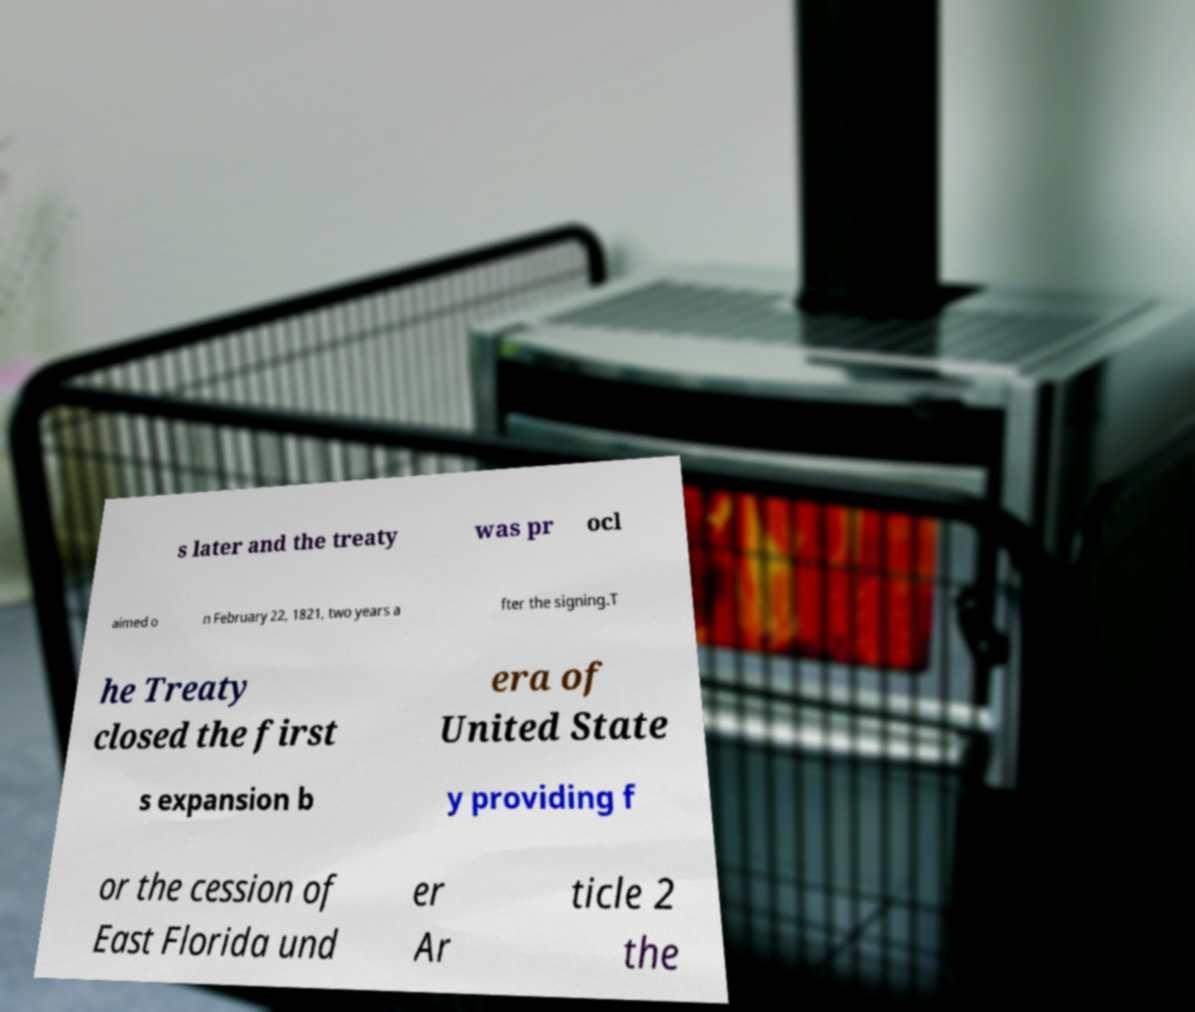There's text embedded in this image that I need extracted. Can you transcribe it verbatim? s later and the treaty was pr ocl aimed o n February 22, 1821, two years a fter the signing.T he Treaty closed the first era of United State s expansion b y providing f or the cession of East Florida und er Ar ticle 2 the 